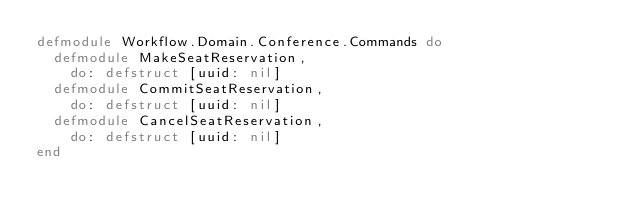Convert code to text. <code><loc_0><loc_0><loc_500><loc_500><_Elixir_>defmodule Workflow.Domain.Conference.Commands do
  defmodule MakeSeatReservation,
    do: defstruct [uuid: nil]
  defmodule CommitSeatReservation,
    do: defstruct [uuid: nil]
  defmodule CancelSeatReservation,
    do: defstruct [uuid: nil]
end
</code> 